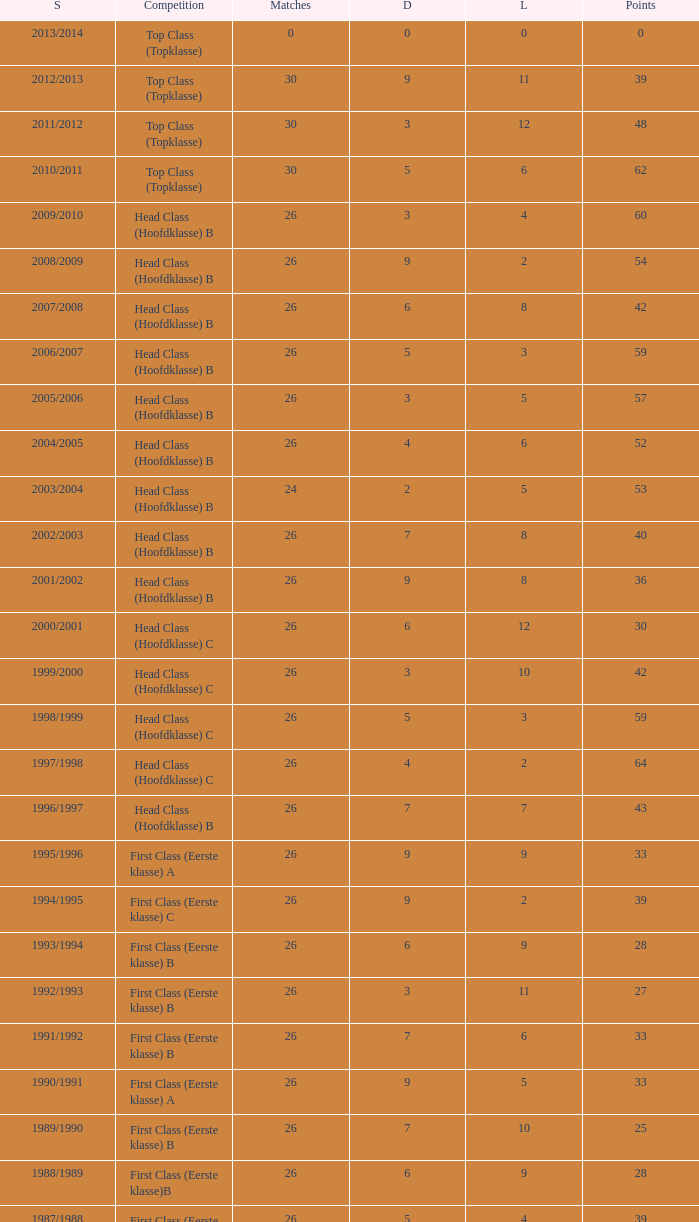What is the total number of matches with a loss less than 5 in the 2008/2009 season and has a draw larger than 9? 0.0. 